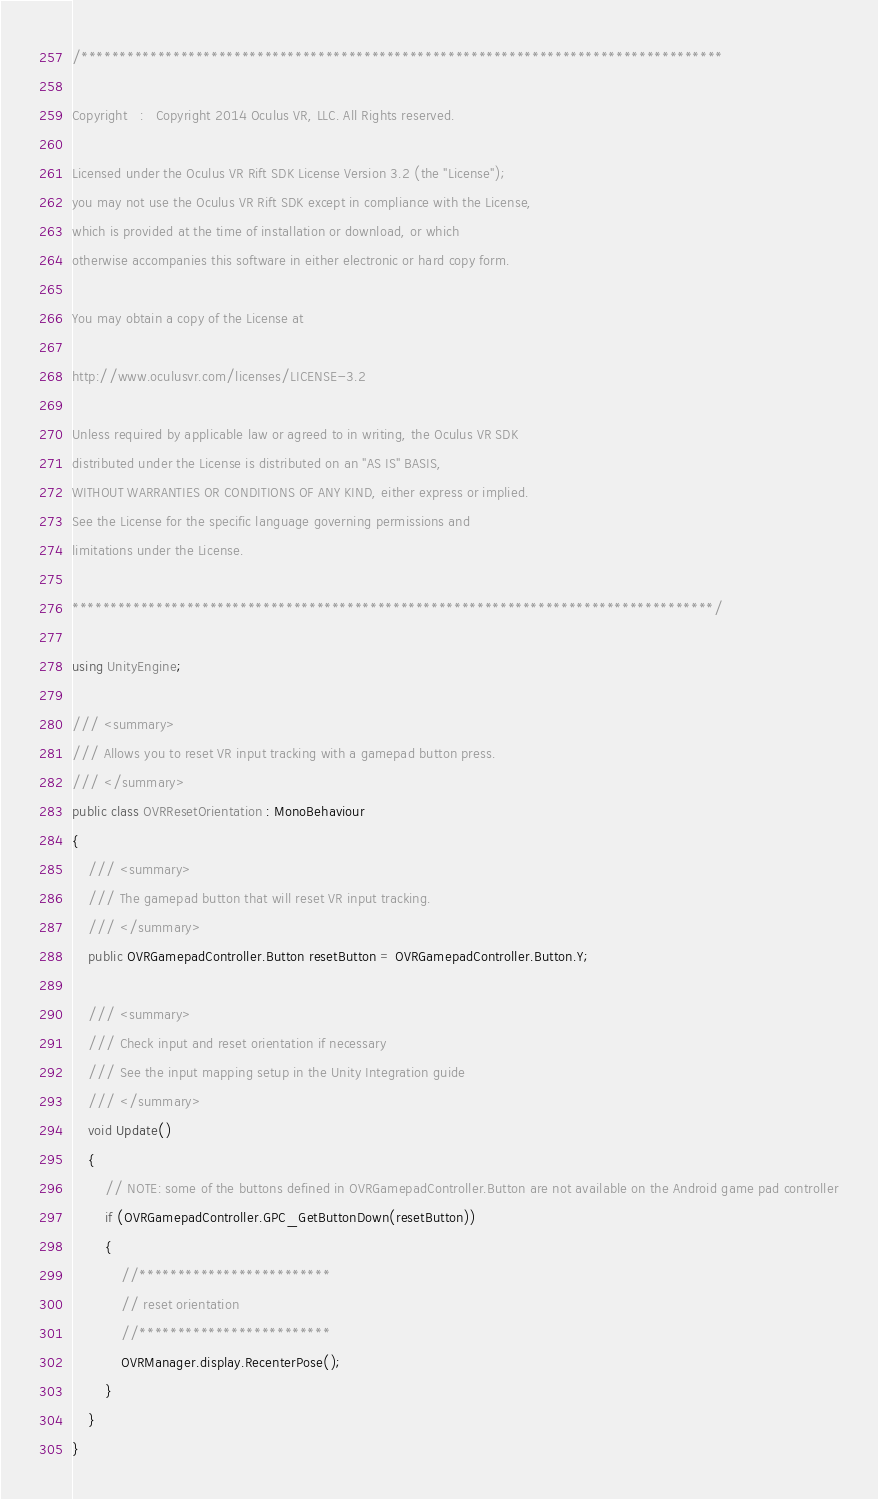<code> <loc_0><loc_0><loc_500><loc_500><_C#_>/************************************************************************************

Copyright   :   Copyright 2014 Oculus VR, LLC. All Rights reserved.

Licensed under the Oculus VR Rift SDK License Version 3.2 (the "License");
you may not use the Oculus VR Rift SDK except in compliance with the License,
which is provided at the time of installation or download, or which
otherwise accompanies this software in either electronic or hard copy form.

You may obtain a copy of the License at

http://www.oculusvr.com/licenses/LICENSE-3.2

Unless required by applicable law or agreed to in writing, the Oculus VR SDK
distributed under the License is distributed on an "AS IS" BASIS,
WITHOUT WARRANTIES OR CONDITIONS OF ANY KIND, either express or implied.
See the License for the specific language governing permissions and
limitations under the License.

************************************************************************************/

using UnityEngine;

/// <summary>
/// Allows you to reset VR input tracking with a gamepad button press.
/// </summary>
public class OVRResetOrientation : MonoBehaviour
{
	/// <summary>
	/// The gamepad button that will reset VR input tracking.
	/// </summary>
	public OVRGamepadController.Button resetButton = OVRGamepadController.Button.Y;

	/// <summary>
	/// Check input and reset orientation if necessary
	/// See the input mapping setup in the Unity Integration guide
	/// </summary>
	void Update()
	{
		// NOTE: some of the buttons defined in OVRGamepadController.Button are not available on the Android game pad controller
		if (OVRGamepadController.GPC_GetButtonDown(resetButton))
		{
			//*************************
			// reset orientation
			//*************************
			OVRManager.display.RecenterPose();
		}
	}
}
</code> 